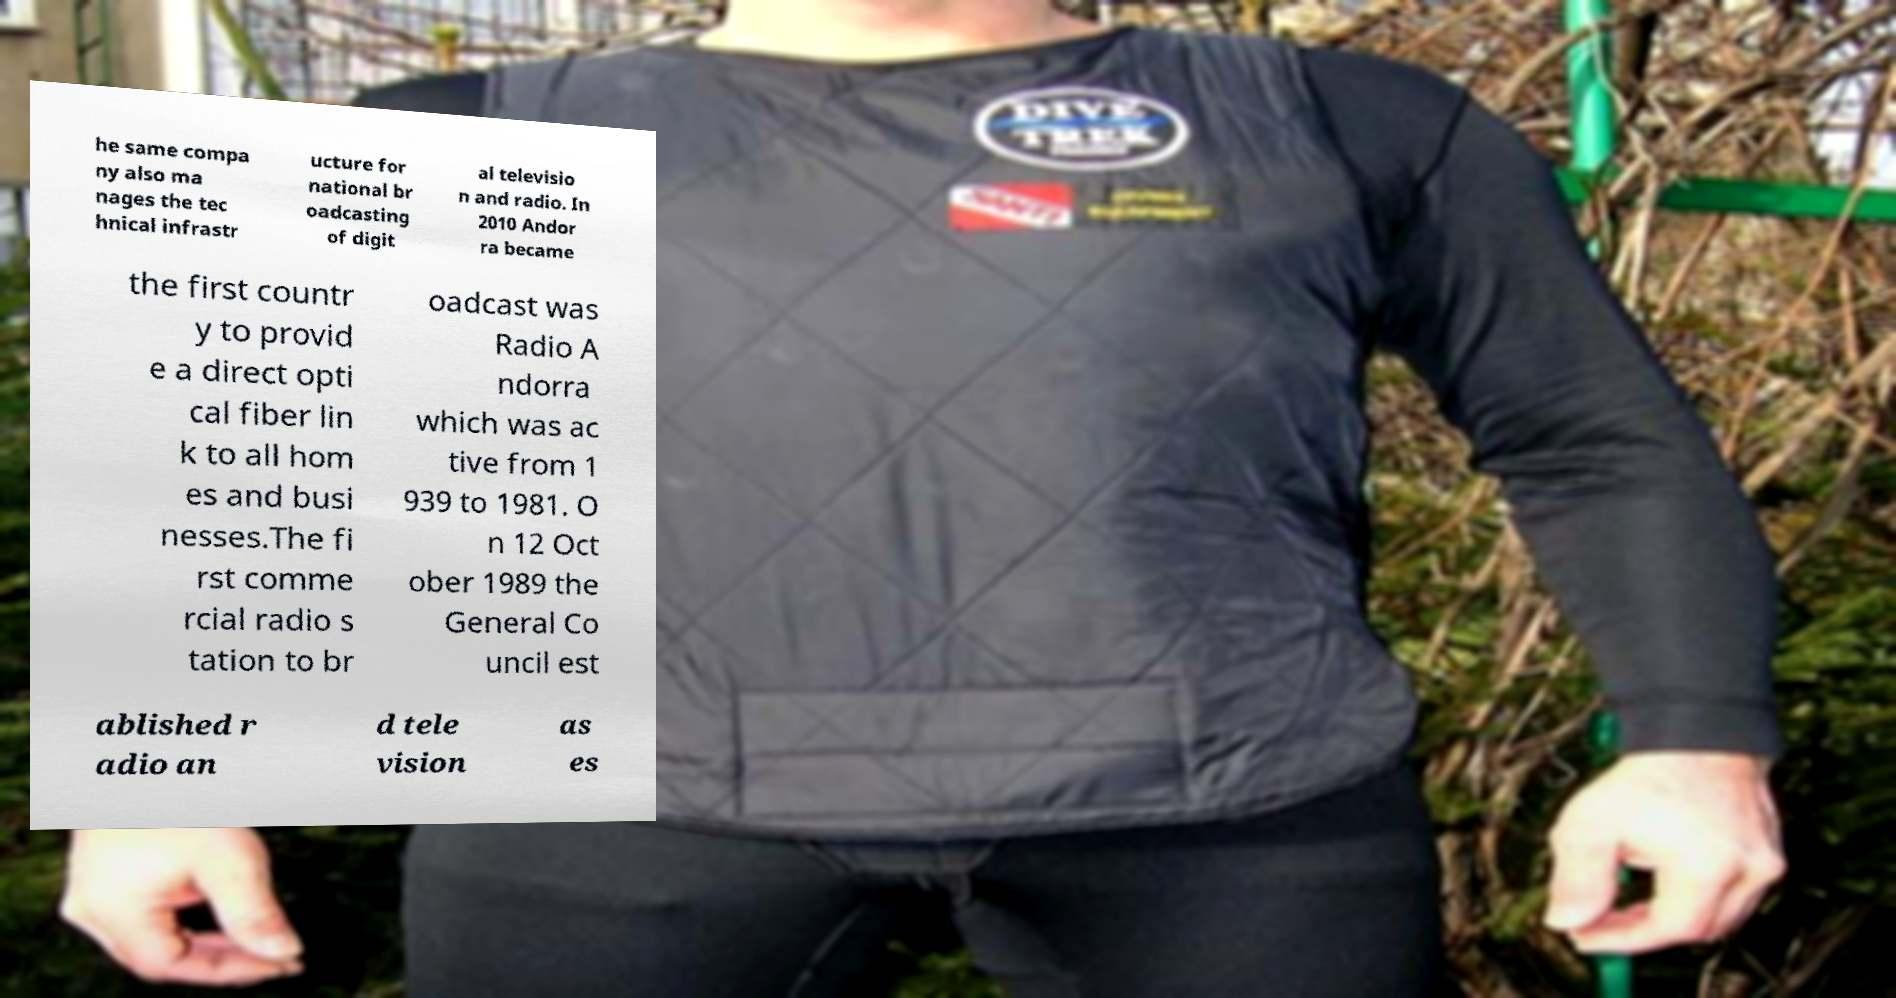There's text embedded in this image that I need extracted. Can you transcribe it verbatim? he same compa ny also ma nages the tec hnical infrastr ucture for national br oadcasting of digit al televisio n and radio. In 2010 Andor ra became the first countr y to provid e a direct opti cal fiber lin k to all hom es and busi nesses.The fi rst comme rcial radio s tation to br oadcast was Radio A ndorra which was ac tive from 1 939 to 1981. O n 12 Oct ober 1989 the General Co uncil est ablished r adio an d tele vision as es 